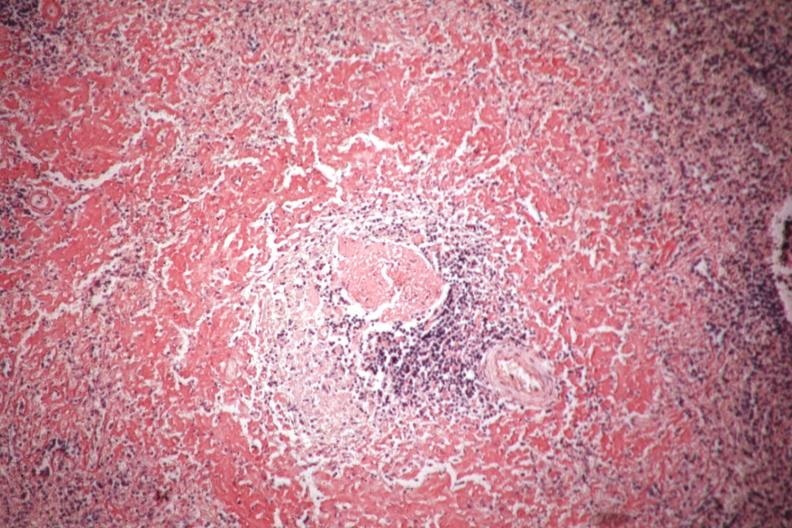does this image show congo red well shown perifollicular amyloid?
Answer the question using a single word or phrase. Yes 